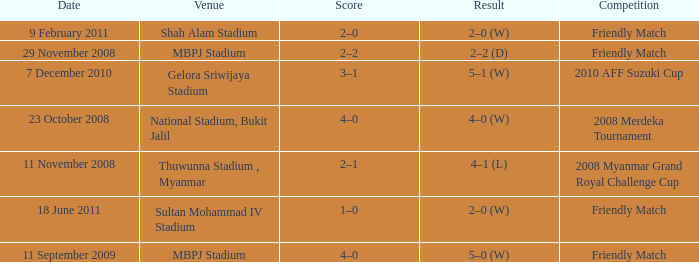What is the Venue of the Competition with a Result of 2–2 (d)? MBPJ Stadium. 